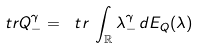Convert formula to latex. <formula><loc_0><loc_0><loc_500><loc_500>\ t r Q _ { - } ^ { \gamma } = \ t r \, \int _ { \mathbb { R } } \lambda _ { - } ^ { \gamma } \, d E _ { Q } ( \lambda )</formula> 